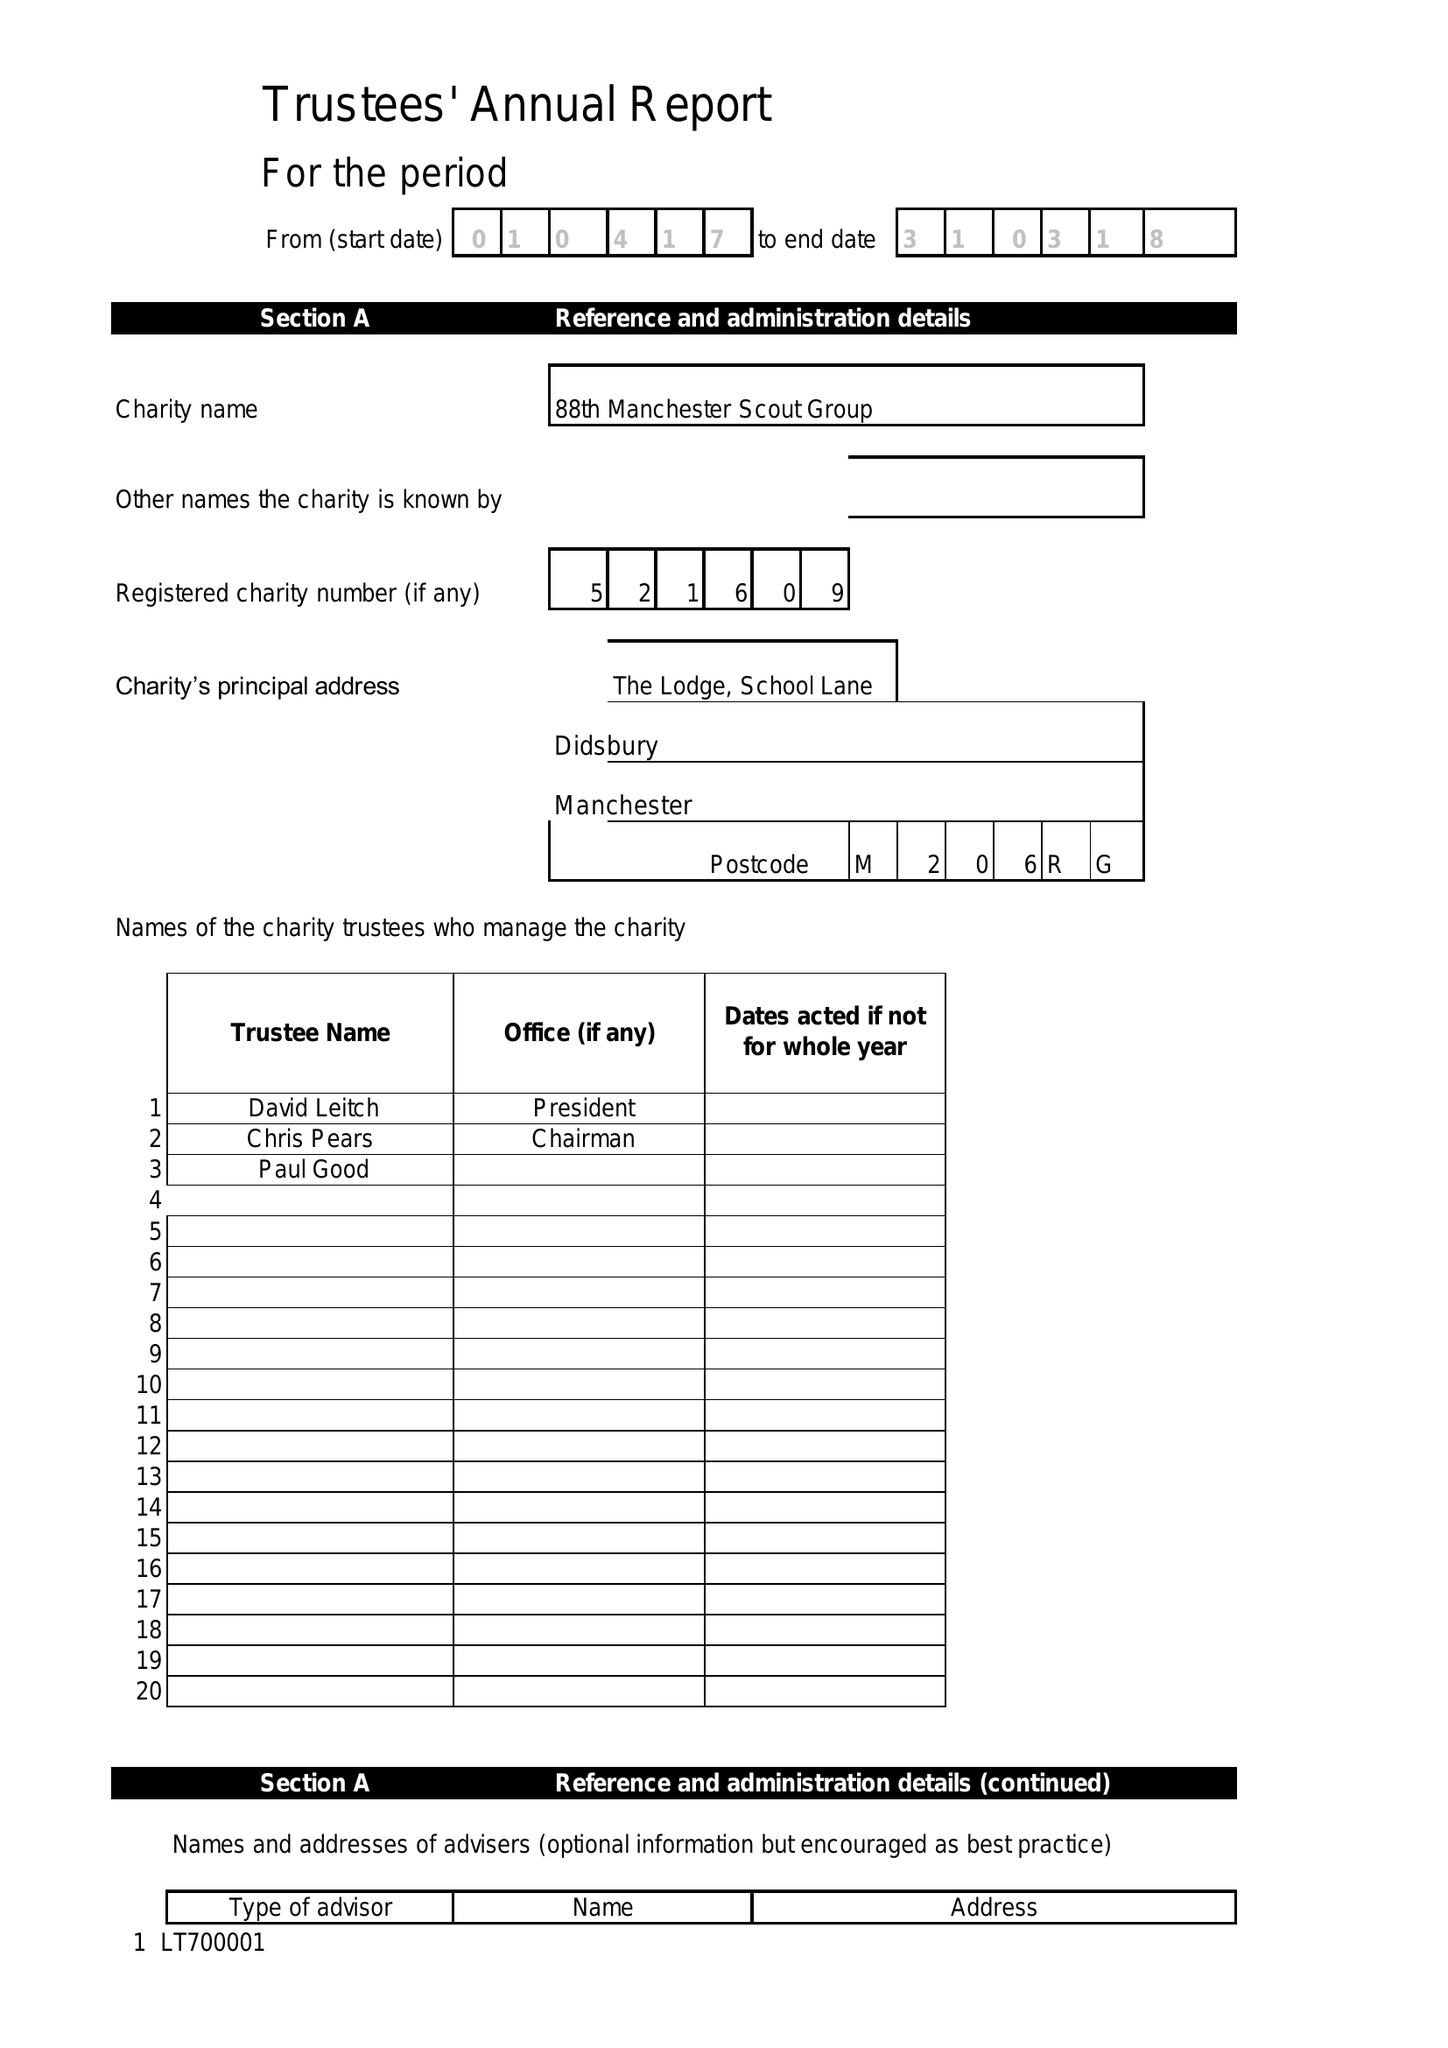What is the value for the charity_number?
Answer the question using a single word or phrase. 521609 